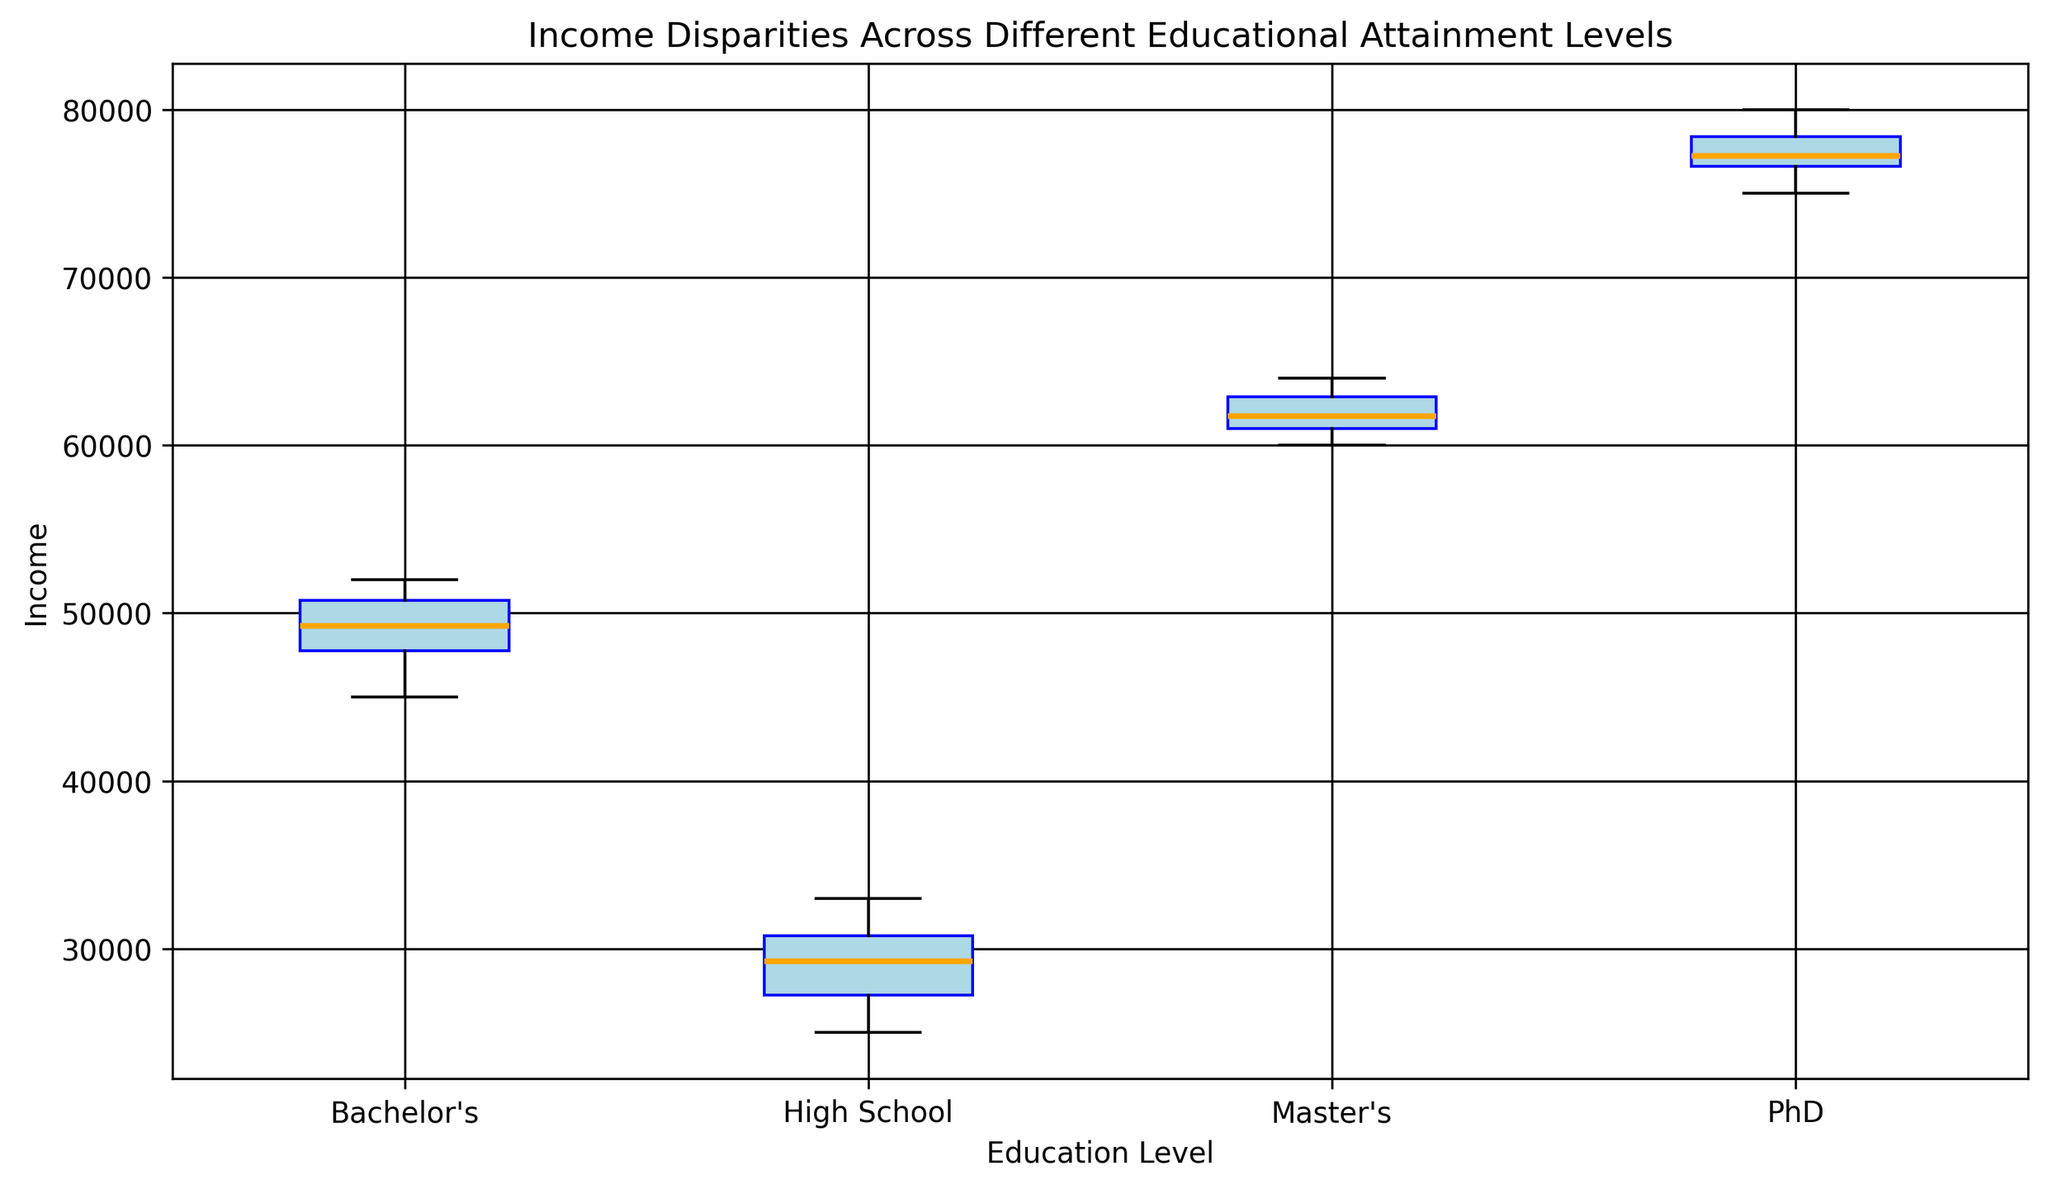What is the median income for individuals with a Bachelor's degree? Find the middle value in the income data points for individuals with a Bachelor's degree, which is sorted in ascending order. There are 10 data points, so the median is the average of the 5th and 6th values: (49000 + 49500) / 2
Answer: 49250 Which education level has the highest median income? Look at the median line (orange line) for each box plot and identify the one with the highest position. The PhD group has the highest median line.
Answer: PhD By how much does the median income of Master's degree holders exceed that of Bachelor's degree holders? Identify the median incomes for both degree holders. Median for Master’s: 61500. Median for Bachelor's: 49250. Calculate the difference: 61500 - 49250
Answer: 12250 What is the range of incomes for individuals with a high school education? Identify the minimum and maximum values within the spread of the whiskers for the High School box plot. Minimum: 25000, Maximum: 33000. Range = 33000 - 25000
Answer: 8000 Which education level shows the widest interquartile range (IQR)? The IQR is the length of the box in each box plot. Compare the lengths of the boxes. PhD has the shortest, while Bachelor's has the widest box.
Answer: Bachelor's How do the median incomes for Master's and PhD compare visually? Inspect the positions of the orange lines (median) for both Master's and PhD. The orange line for Master's is slightly lower than that for PhD.
Answer: PhD is higher What is the relation between the whiskers' length and the variability in income within each education level? Longer whiskers indicate a wider range and higher variability in the income distribution, while shorter whiskers indicate lesser variability. Compare whiskers across all education levels.
Answer: Whisker length corresponds to variability Which education level has the most outliers in the data? Identify the number of outlier points marked in red for each education level. Bachelor's has several red points indicating outliers.
Answer: Bachelor's What seems to be the minimum income for PhD holders? Look at the lower whisker end for the PhD box plot. The minimum income is identified as the end of the lower whisker.
Answer: 75000 By how much does the interquartile range (IQR) of High School compare to PhD? Calculate IQR for both levels: IQR for High School = Q3 (31000) - Q1 (27375) = 3625; IQR for PhD = Q3 (78000) - Q1 (76500) = 1500. Compute the difference: 3625 - 1500
Answer: 2125 